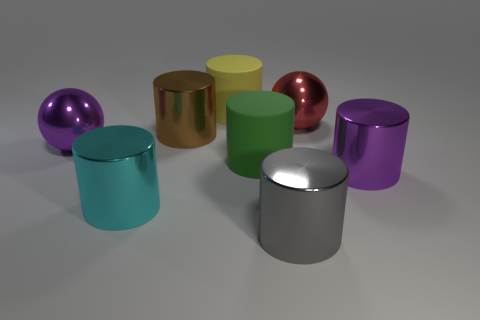Subtract all large cyan metal cylinders. How many cylinders are left? 5 Subtract all purple cylinders. How many cylinders are left? 5 Add 1 purple metal spheres. How many objects exist? 9 Subtract 1 cylinders. How many cylinders are left? 5 Subtract 0 green cubes. How many objects are left? 8 Subtract all balls. How many objects are left? 6 Subtract all cyan spheres. Subtract all yellow cylinders. How many spheres are left? 2 Subtract all blue balls. How many brown cylinders are left? 1 Subtract all large matte cylinders. Subtract all matte cylinders. How many objects are left? 4 Add 8 big purple metal cylinders. How many big purple metal cylinders are left? 9 